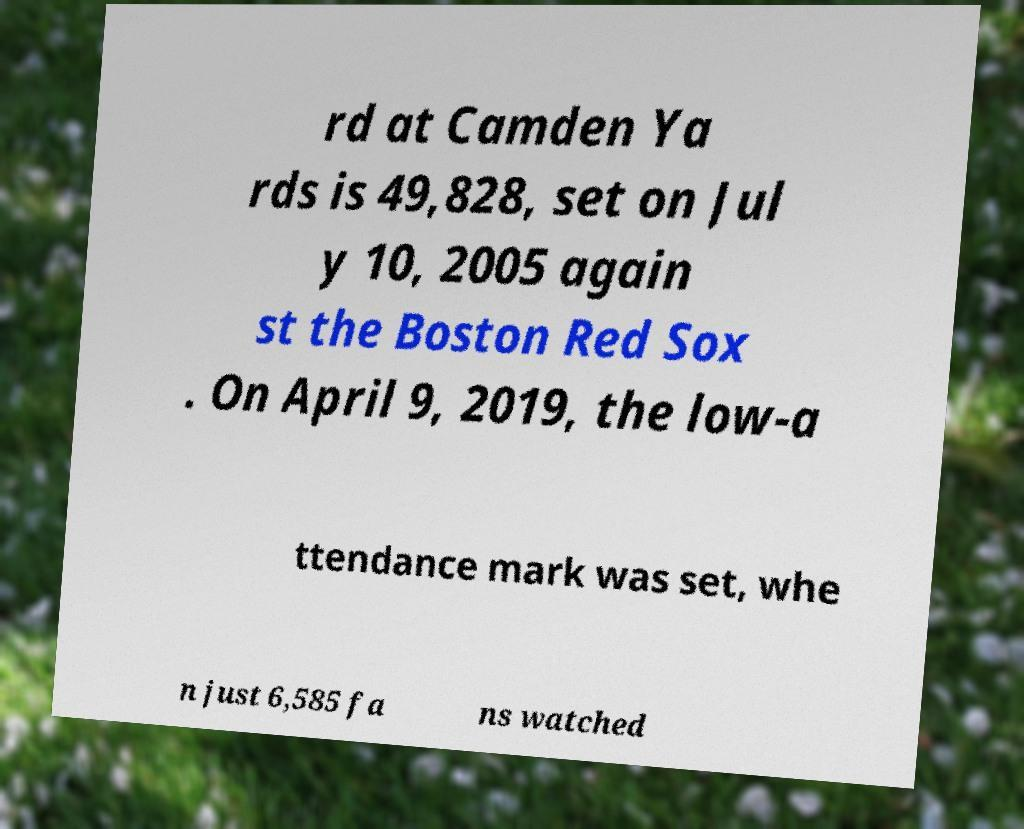Please identify and transcribe the text found in this image. rd at Camden Ya rds is 49,828, set on Jul y 10, 2005 again st the Boston Red Sox . On April 9, 2019, the low-a ttendance mark was set, whe n just 6,585 fa ns watched 